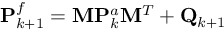<formula> <loc_0><loc_0><loc_500><loc_500>P _ { k + 1 } ^ { f } = M P _ { k } ^ { a } M ^ { T } + Q _ { k + 1 }</formula> 